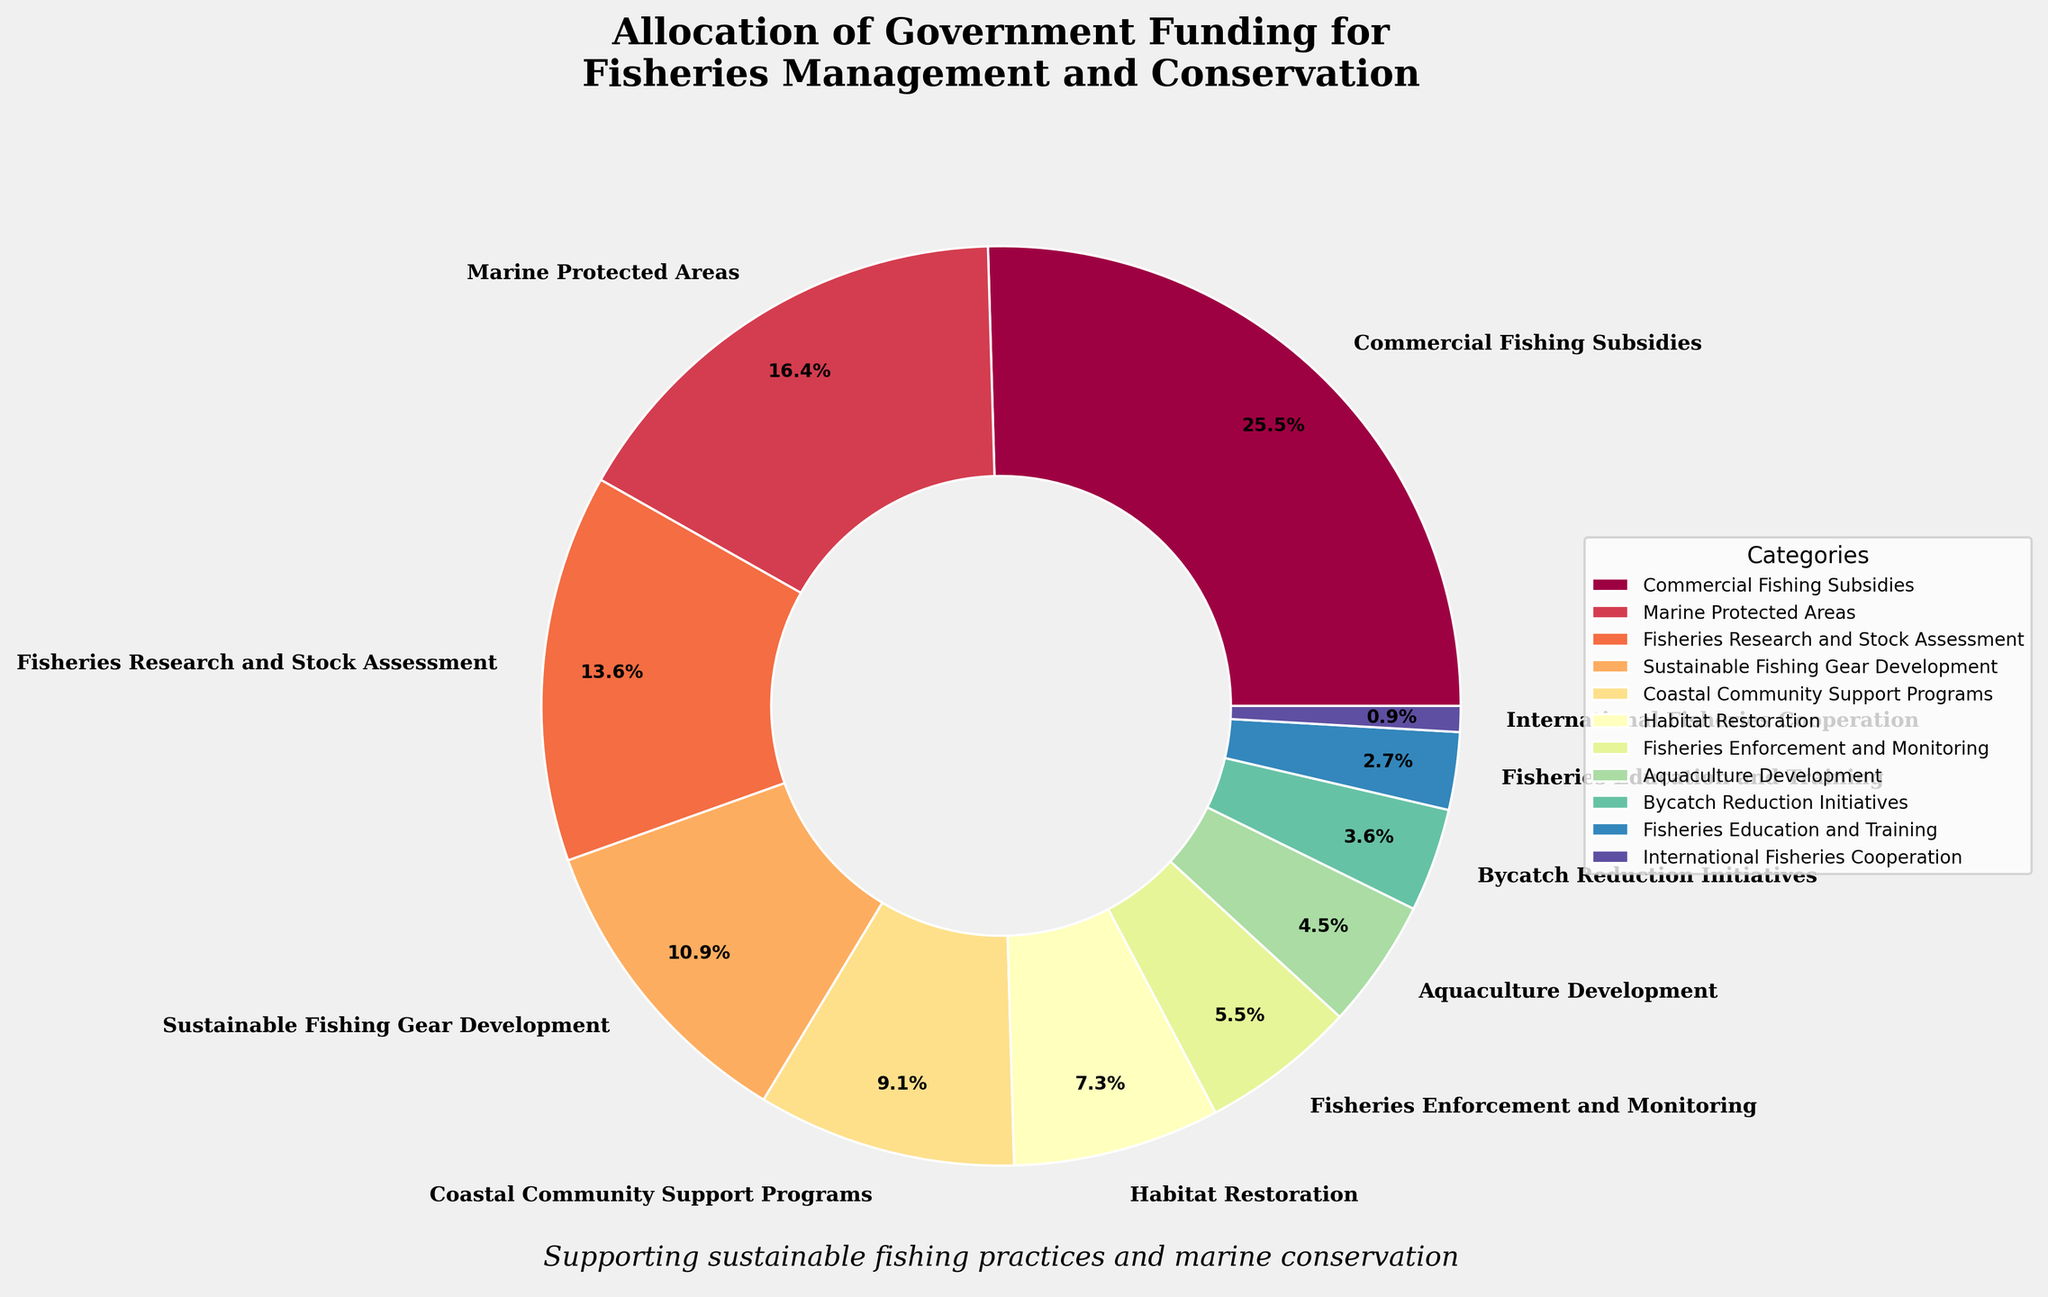What's the total percentage allocated to Fisheries Research and Stock Assessment and Sustainable Fishing Gear Development? Add the percentages for Fisheries Research and Stock Assessment (15%) and Sustainable Fishing Gear Development (12%) which gives 15 + 12 = 27.
Answer: 27% Which sector receives more funding: Coastal Community Support Programs or Habitat Restoration? Compare the percentages for Coastal Community Support Programs (10%) and Habitat Restoration (8%). Coastal Community Support Programs have a higher percentage.
Answer: Coastal Community Support Programs Is the allocation for Marine Protected Areas greater than that for Commercial Fishing Subsidies? Compare the percentages for Marine Protected Areas (18%) and Commercial Fishing Subsidies (28%). Marine Protected Areas have a lower percentage than Commercial Fishing Subsidies.
Answer: No What is the combined percentage for Fisheries Enforcement and Monitoring, Aquaculture Development, and International Fisheries Cooperation? Sum the percentages for Fisheries Enforcement and Monitoring (6%), Aquaculture Development (5%), and International Fisheries Cooperation (1%). The combined total is 6 + 5 + 1 = 12.
Answer: 12% Which category is represented with the largest wedge in the pie chart? Identify the category with the highest percentage, which is Commercial Fishing Subsidies at 28%.
Answer: Commercial Fishing Subsidies Which two categories together constitute the same percentage as Commercial Fishing Subsidies alone? Identify two categories whose combined percentage equals that of Commercial Fishing Subsidies, which is 28%. Combine Sustainable Fishing Gear Development (12%) and Coastal Community Support Programs (10%), which make 12 + 10 = 22. This does not match. Instead, combine Marine Protected Areas (18%) and Habitat Restoration (8%), which make 18 + 10 = 26. Still not perfect. Together, 18 and Fisheries Research and Stock Assessment (15%) make more sense as it’s close: 18 + 15 = 33. This is tricky. Possibly a reconsideration is Commercial + another.
Answer: None match exactly, this is complex Is the funding allocation for Fisheries Education and Training lower than Bycatch Reduction Initiatives? Compare the allocations for Fisheries Education and Training (3%) and Bycatch Reduction Initiatives (4%). Fisheries Education and Training has a smaller percentage.
Answer: Yes What is the visual attribute that indicates the difference in percentage allocation for each category? The size of the pie slices (wedges) in the chart represents different percentages allocated to each category. Larger slices indicate higher percentages.
Answer: Size of pie slices Which categories have a percentage allocation less than 10%? List all categories with less than 10% allocation: Habitat Restoration (8%), Fisheries Enforcement and Monitoring (6%), Aquaculture Development (5%), Bycatch Reduction Initiatives (4%), Fisheries Education and Training (3%), and International Fisheries Cooperation (1%).
Answer: Habitat Restoration, Fisheries Enforcement and Monitoring, Aquaculture Development, Bycatch Reduction Initiatives, Fisheries Education and Training, International Fisheries Cooperation If you combine the allocations for Coastal Community Support Programs and Habitat Restoration, do they exceed Marine Protected Areas? Add the percentages for Coastal Community Support Programs (10%) and Habitat Restoration (8%), giving 10 + 8 = 18. Marine Protected Areas are also 18%, so the combined percentage equals it.
Answer: No 